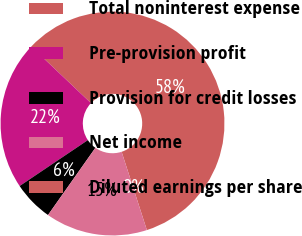Convert chart. <chart><loc_0><loc_0><loc_500><loc_500><pie_chart><fcel>Total noninterest expense<fcel>Pre-provision profit<fcel>Provision for credit losses<fcel>Net income<fcel>Diluted earnings per share<nl><fcel>57.96%<fcel>21.5%<fcel>5.8%<fcel>14.74%<fcel>0.0%<nl></chart> 